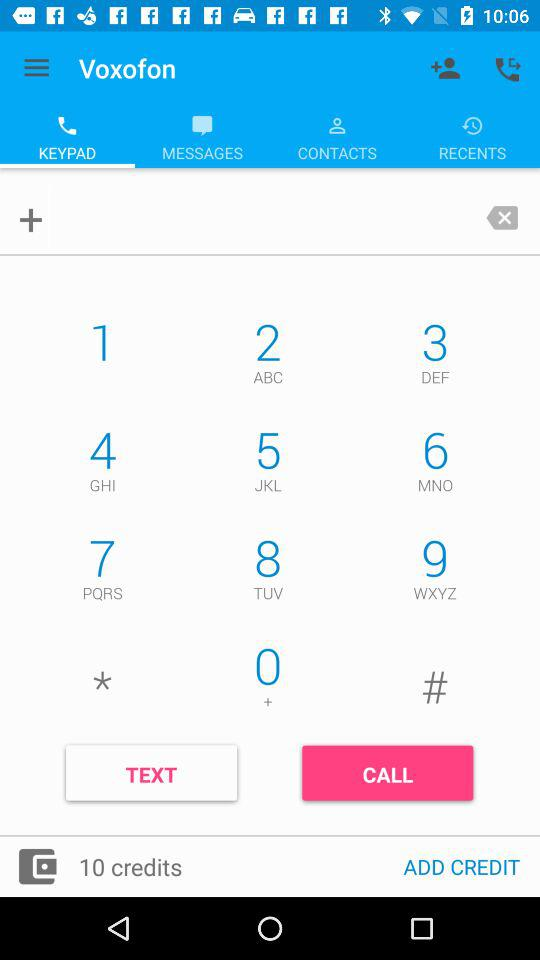Which tab has been selected? The tab that has been selected is "KEYPAD". 